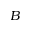<formula> <loc_0><loc_0><loc_500><loc_500>B</formula> 